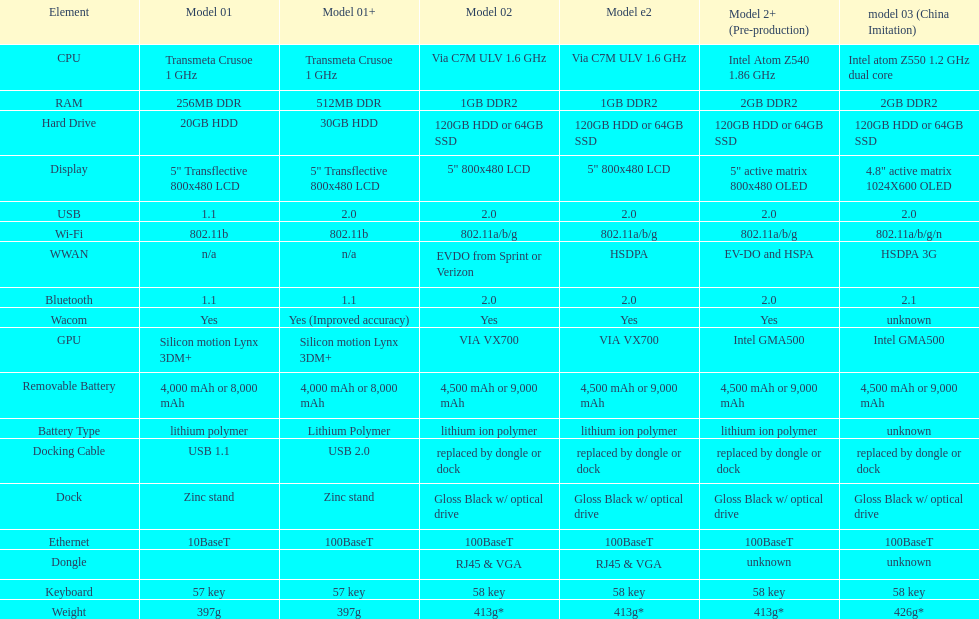What is the next highest hard drive available after the 30gb model? 64GB SSD. 